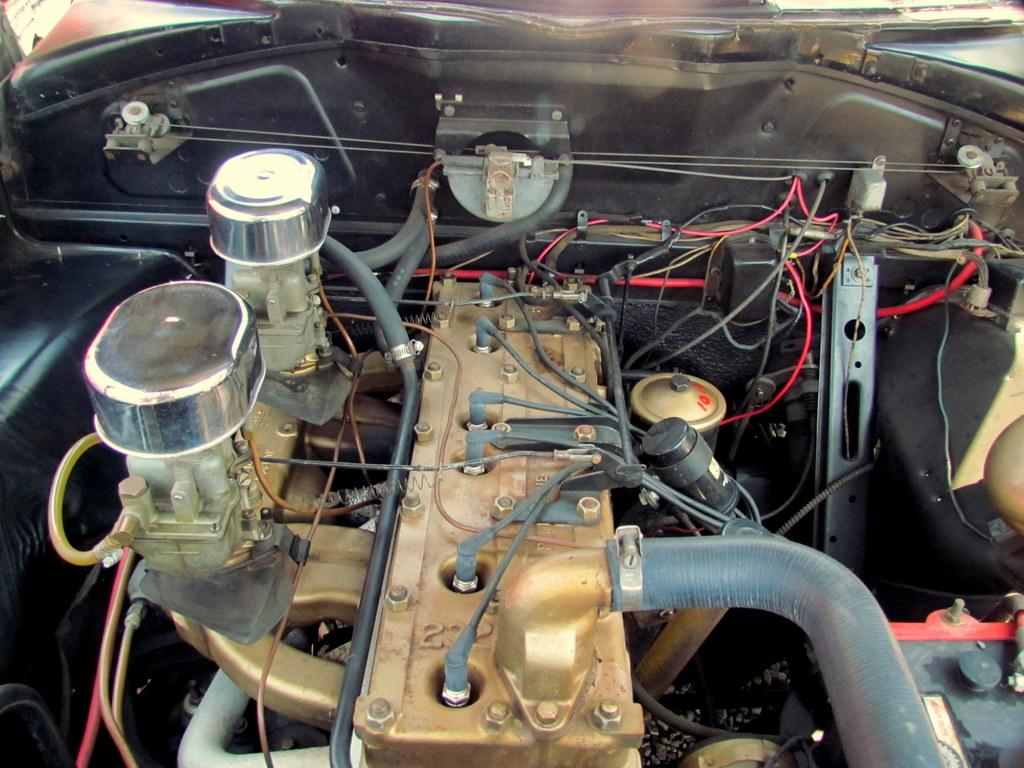What is the main subject of the image? The main subject of the image is a car. What part of the car can be seen in the image? The engine of the car is visible in the image. What else is present in the image besides the car? There are many wires in the image. Can you see any toads swimming in the image? There are no toads or swimming activity present in the image. 